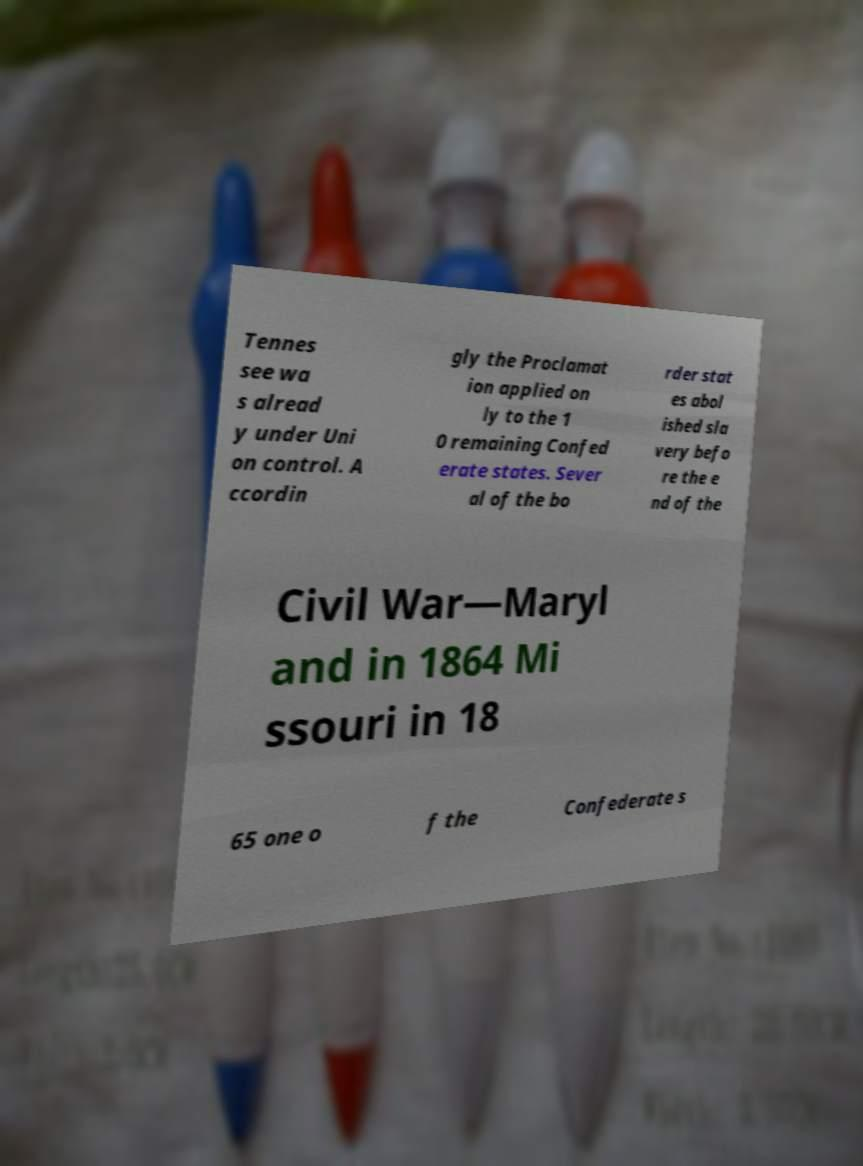Could you assist in decoding the text presented in this image and type it out clearly? Tennes see wa s alread y under Uni on control. A ccordin gly the Proclamat ion applied on ly to the 1 0 remaining Confed erate states. Sever al of the bo rder stat es abol ished sla very befo re the e nd of the Civil War—Maryl and in 1864 Mi ssouri in 18 65 one o f the Confederate s 